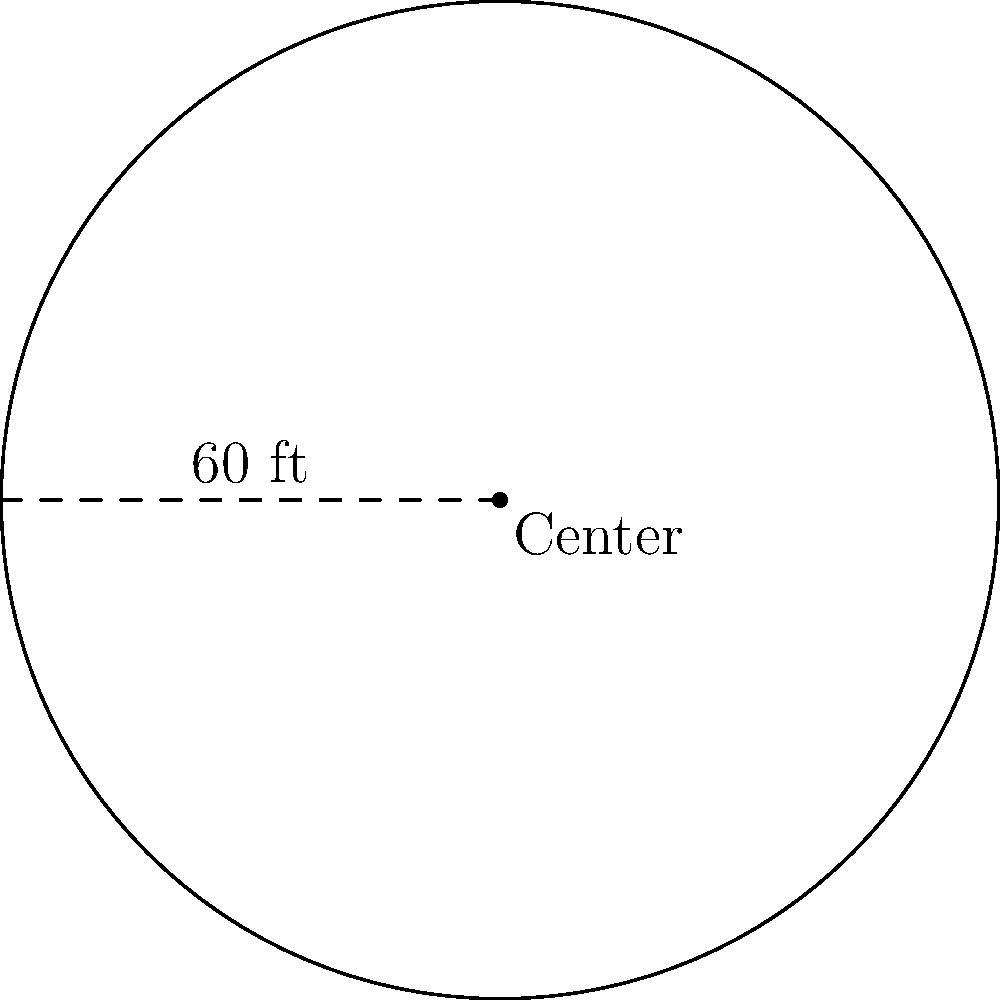At the annual North Texas Agricultural College reunion, a circular exhibition space is being set up to showcase vintage farm equipment. If the radius of this circular area is 60 feet, what is the perimeter of the exhibition space? To find the perimeter of a circular area, we need to calculate its circumference. The formula for the circumference of a circle is:

$$C = 2\pi r$$

Where:
$C$ = circumference
$\pi$ = pi (approximately 3.14159)
$r$ = radius

Given:
Radius = 60 feet

Let's substitute these values into the formula:

$$C = 2 \times \pi \times 60$$

$$C = 2 \times 3.14159 \times 60$$

$$C = 376.99 \text{ feet}$$

Rounding to the nearest foot:

$$C \approx 377 \text{ feet}$$

Therefore, the perimeter of the circular vintage farm equipment exhibition space is approximately 377 feet.
Answer: 377 feet 